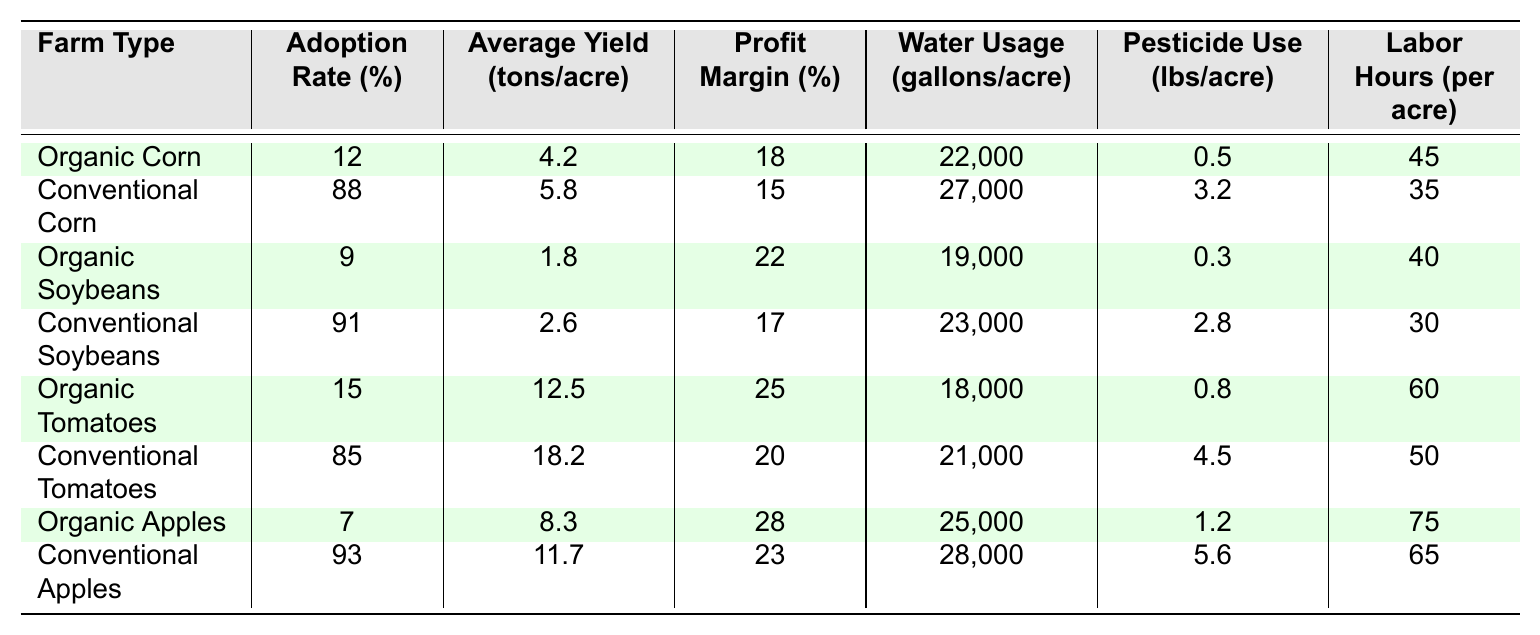What is the adoption rate of organic corn? The adoption rate of organic corn is stated directly in the table under the "Adoption Rate (%)" column for "Organic Corn."
Answer: 12% What is the average yield of conventional tomatoes? The average yield for conventional tomatoes can be found in the "Average Yield (tons/acre)" column corresponding to "Conventional Tomatoes."
Answer: 18.2 tons/acre Which farm type has the highest profit margin? By scanning the "Profit Margin (%)" column, the highest value is found next to "Organic Apples," indicating that this farm type has the highest profit margin.
Answer: Organic Apples How much water is used per acre in conventional soybeans? The water usage for conventional soybeans is listed in the "Water Usage (gallons/acre)" column for "Conventional Soybeans."
Answer: 23,000 gallons/acre What is the difference in average yield between organic and conventional apples? The average yield for organic apples is 8.3 tons/acre, and for conventional apples, it is 11.7 tons/acre. The difference is calculated as 11.7 - 8.3 = 3.4 tons/acre.
Answer: 3.4 tons/acre Is the profit margin for organic corn greater than that of conventional corn? The profit margin for organic corn is 18%, while for conventional corn, it is 15%. Since 18% is greater than 15%, the statement is true.
Answer: Yes What is the total pesticide use for organic soybeans and organic tomatoes combined? The pesticide use for organic soybeans is 0.3 lbs/acre and for organic tomatoes is 0.8 lbs/acre. Combined, the total is 0.3 + 0.8 = 1.1 lbs/acre.
Answer: 1.1 lbs/acre Which farm type uses less water on average, organic or conventional? To determine this, we can calculate the average water usage for both organic and conventional farm types based on the figures provided for each crop. The average water usage for organic crops is (22000 + 19000 + 18000 + 25000)/4 = 21500 gallons/acre, and for conventional crops it is (27000 + 23000 + 21000 + 28000)/4 = 24750 gallons/acre. Since 21500 is less than 24750, organic farm types use less water on average.
Answer: Organic farm types Which type of farming has a lower average labor hour requirement per acre, organic or conventional? The average labor hours per acre for organic crops are (45 + 40 + 60 + 75)/4 = 55 hours/acre, while for conventional crops it is (35 + 30 + 50 + 65)/4 = 45 hours/acre. Since 55 hours is greater than 45 hours, conventional farming has lower average labor hours.
Answer: Conventional farming 